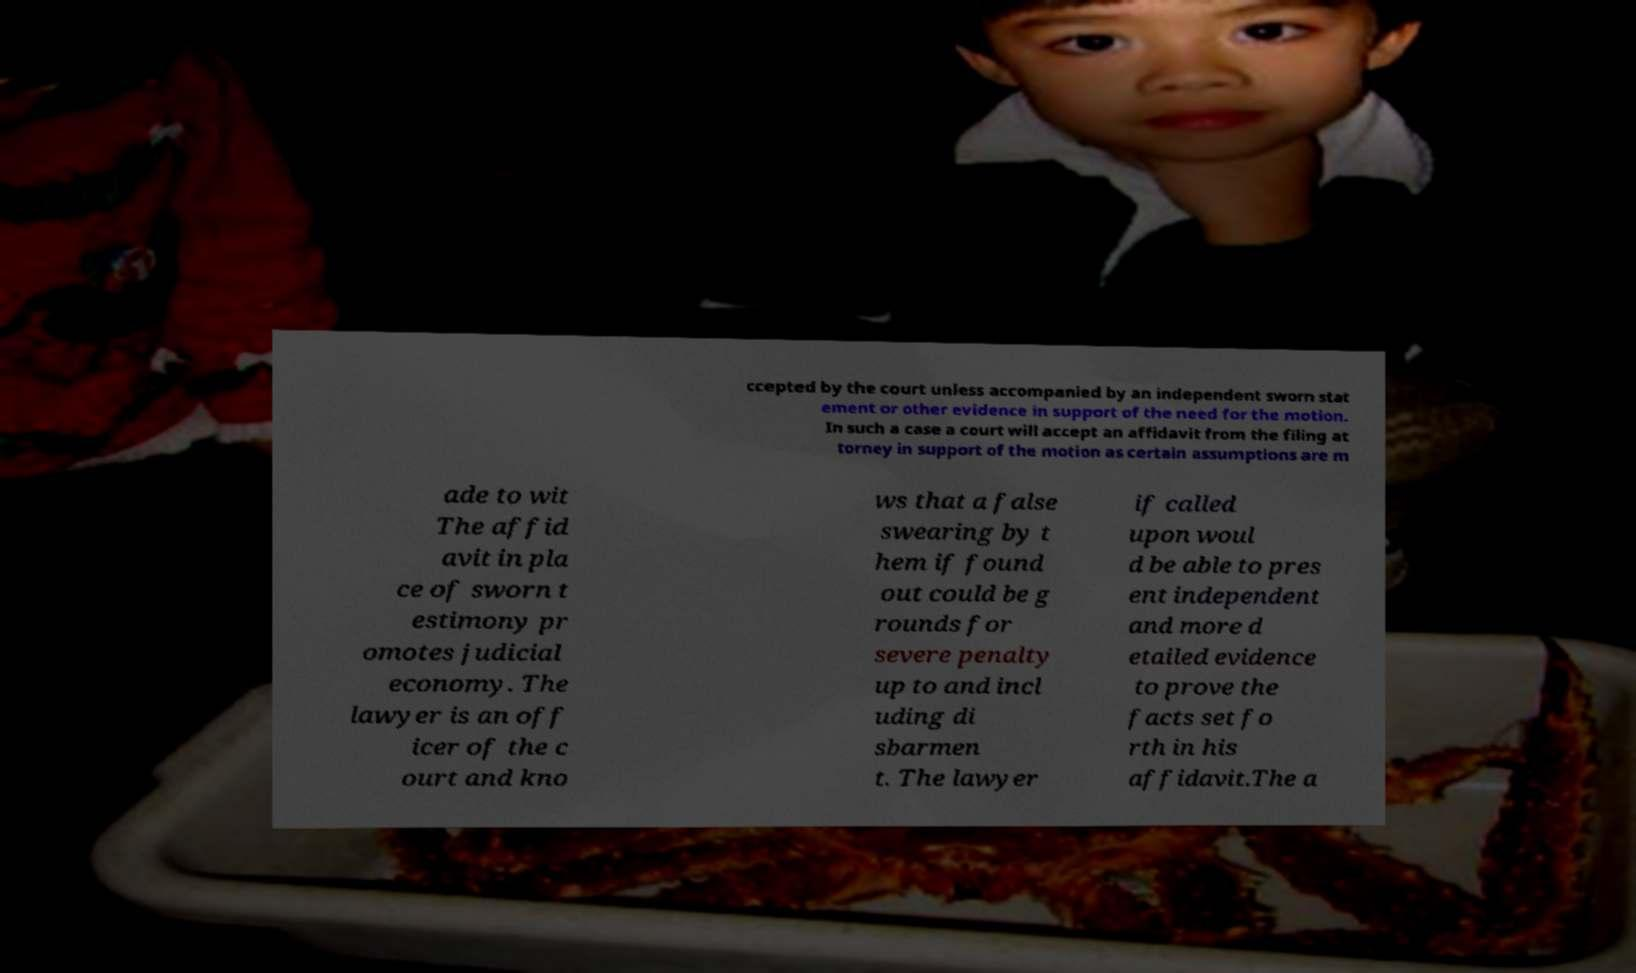Could you assist in decoding the text presented in this image and type it out clearly? ccepted by the court unless accompanied by an independent sworn stat ement or other evidence in support of the need for the motion. In such a case a court will accept an affidavit from the filing at torney in support of the motion as certain assumptions are m ade to wit The affid avit in pla ce of sworn t estimony pr omotes judicial economy. The lawyer is an off icer of the c ourt and kno ws that a false swearing by t hem if found out could be g rounds for severe penalty up to and incl uding di sbarmen t. The lawyer if called upon woul d be able to pres ent independent and more d etailed evidence to prove the facts set fo rth in his affidavit.The a 